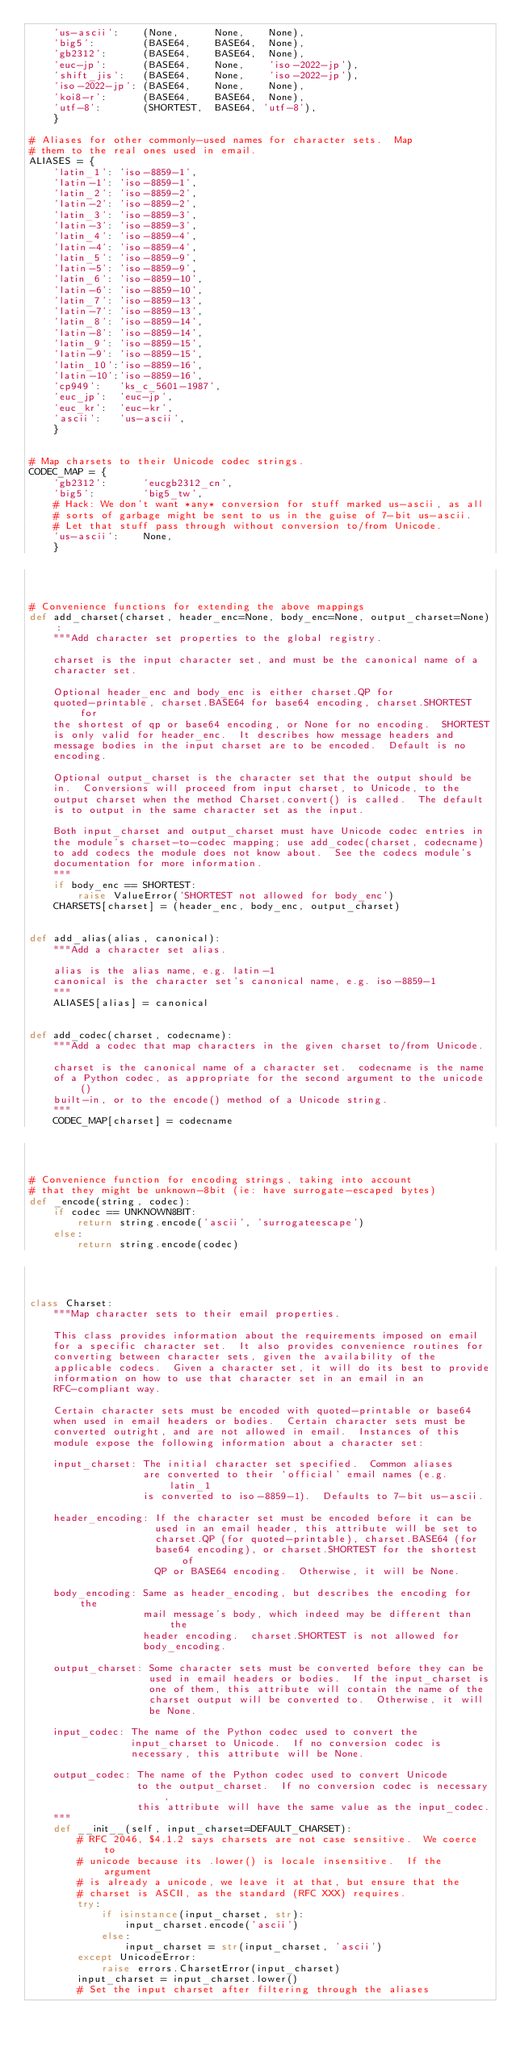Convert code to text. <code><loc_0><loc_0><loc_500><loc_500><_Python_>    'us-ascii':    (None,      None,    None),
    'big5':        (BASE64,    BASE64,  None),
    'gb2312':      (BASE64,    BASE64,  None),
    'euc-jp':      (BASE64,    None,    'iso-2022-jp'),
    'shift_jis':   (BASE64,    None,    'iso-2022-jp'),
    'iso-2022-jp': (BASE64,    None,    None),
    'koi8-r':      (BASE64,    BASE64,  None),
    'utf-8':       (SHORTEST,  BASE64, 'utf-8'),
    }

# Aliases for other commonly-used names for character sets.  Map
# them to the real ones used in email.
ALIASES = {
    'latin_1': 'iso-8859-1',
    'latin-1': 'iso-8859-1',
    'latin_2': 'iso-8859-2',
    'latin-2': 'iso-8859-2',
    'latin_3': 'iso-8859-3',
    'latin-3': 'iso-8859-3',
    'latin_4': 'iso-8859-4',
    'latin-4': 'iso-8859-4',
    'latin_5': 'iso-8859-9',
    'latin-5': 'iso-8859-9',
    'latin_6': 'iso-8859-10',
    'latin-6': 'iso-8859-10',
    'latin_7': 'iso-8859-13',
    'latin-7': 'iso-8859-13',
    'latin_8': 'iso-8859-14',
    'latin-8': 'iso-8859-14',
    'latin_9': 'iso-8859-15',
    'latin-9': 'iso-8859-15',
    'latin_10':'iso-8859-16',
    'latin-10':'iso-8859-16',
    'cp949':   'ks_c_5601-1987',
    'euc_jp':  'euc-jp',
    'euc_kr':  'euc-kr',
    'ascii':   'us-ascii',
    }


# Map charsets to their Unicode codec strings.
CODEC_MAP = {
    'gb2312':      'eucgb2312_cn',
    'big5':        'big5_tw',
    # Hack: We don't want *any* conversion for stuff marked us-ascii, as all
    # sorts of garbage might be sent to us in the guise of 7-bit us-ascii.
    # Let that stuff pass through without conversion to/from Unicode.
    'us-ascii':    None,
    }



# Convenience functions for extending the above mappings
def add_charset(charset, header_enc=None, body_enc=None, output_charset=None):
    """Add character set properties to the global registry.

    charset is the input character set, and must be the canonical name of a
    character set.

    Optional header_enc and body_enc is either charset.QP for
    quoted-printable, charset.BASE64 for base64 encoding, charset.SHORTEST for
    the shortest of qp or base64 encoding, or None for no encoding.  SHORTEST
    is only valid for header_enc.  It describes how message headers and
    message bodies in the input charset are to be encoded.  Default is no
    encoding.

    Optional output_charset is the character set that the output should be
    in.  Conversions will proceed from input charset, to Unicode, to the
    output charset when the method Charset.convert() is called.  The default
    is to output in the same character set as the input.

    Both input_charset and output_charset must have Unicode codec entries in
    the module's charset-to-codec mapping; use add_codec(charset, codecname)
    to add codecs the module does not know about.  See the codecs module's
    documentation for more information.
    """
    if body_enc == SHORTEST:
        raise ValueError('SHORTEST not allowed for body_enc')
    CHARSETS[charset] = (header_enc, body_enc, output_charset)


def add_alias(alias, canonical):
    """Add a character set alias.

    alias is the alias name, e.g. latin-1
    canonical is the character set's canonical name, e.g. iso-8859-1
    """
    ALIASES[alias] = canonical


def add_codec(charset, codecname):
    """Add a codec that map characters in the given charset to/from Unicode.

    charset is the canonical name of a character set.  codecname is the name
    of a Python codec, as appropriate for the second argument to the unicode()
    built-in, or to the encode() method of a Unicode string.
    """
    CODEC_MAP[charset] = codecname



# Convenience function for encoding strings, taking into account
# that they might be unknown-8bit (ie: have surrogate-escaped bytes)
def _encode(string, codec):
    if codec == UNKNOWN8BIT:
        return string.encode('ascii', 'surrogateescape')
    else:
        return string.encode(codec)



class Charset:
    """Map character sets to their email properties.

    This class provides information about the requirements imposed on email
    for a specific character set.  It also provides convenience routines for
    converting between character sets, given the availability of the
    applicable codecs.  Given a character set, it will do its best to provide
    information on how to use that character set in an email in an
    RFC-compliant way.

    Certain character sets must be encoded with quoted-printable or base64
    when used in email headers or bodies.  Certain character sets must be
    converted outright, and are not allowed in email.  Instances of this
    module expose the following information about a character set:

    input_charset: The initial character set specified.  Common aliases
                   are converted to their `official' email names (e.g. latin_1
                   is converted to iso-8859-1).  Defaults to 7-bit us-ascii.

    header_encoding: If the character set must be encoded before it can be
                     used in an email header, this attribute will be set to
                     charset.QP (for quoted-printable), charset.BASE64 (for
                     base64 encoding), or charset.SHORTEST for the shortest of
                     QP or BASE64 encoding.  Otherwise, it will be None.

    body_encoding: Same as header_encoding, but describes the encoding for the
                   mail message's body, which indeed may be different than the
                   header encoding.  charset.SHORTEST is not allowed for
                   body_encoding.

    output_charset: Some character sets must be converted before they can be
                    used in email headers or bodies.  If the input_charset is
                    one of them, this attribute will contain the name of the
                    charset output will be converted to.  Otherwise, it will
                    be None.

    input_codec: The name of the Python codec used to convert the
                 input_charset to Unicode.  If no conversion codec is
                 necessary, this attribute will be None.

    output_codec: The name of the Python codec used to convert Unicode
                  to the output_charset.  If no conversion codec is necessary,
                  this attribute will have the same value as the input_codec.
    """
    def __init__(self, input_charset=DEFAULT_CHARSET):
        # RFC 2046, $4.1.2 says charsets are not case sensitive.  We coerce to
        # unicode because its .lower() is locale insensitive.  If the argument
        # is already a unicode, we leave it at that, but ensure that the
        # charset is ASCII, as the standard (RFC XXX) requires.
        try:
            if isinstance(input_charset, str):
                input_charset.encode('ascii')
            else:
                input_charset = str(input_charset, 'ascii')
        except UnicodeError:
            raise errors.CharsetError(input_charset)
        input_charset = input_charset.lower()
        # Set the input charset after filtering through the aliases</code> 